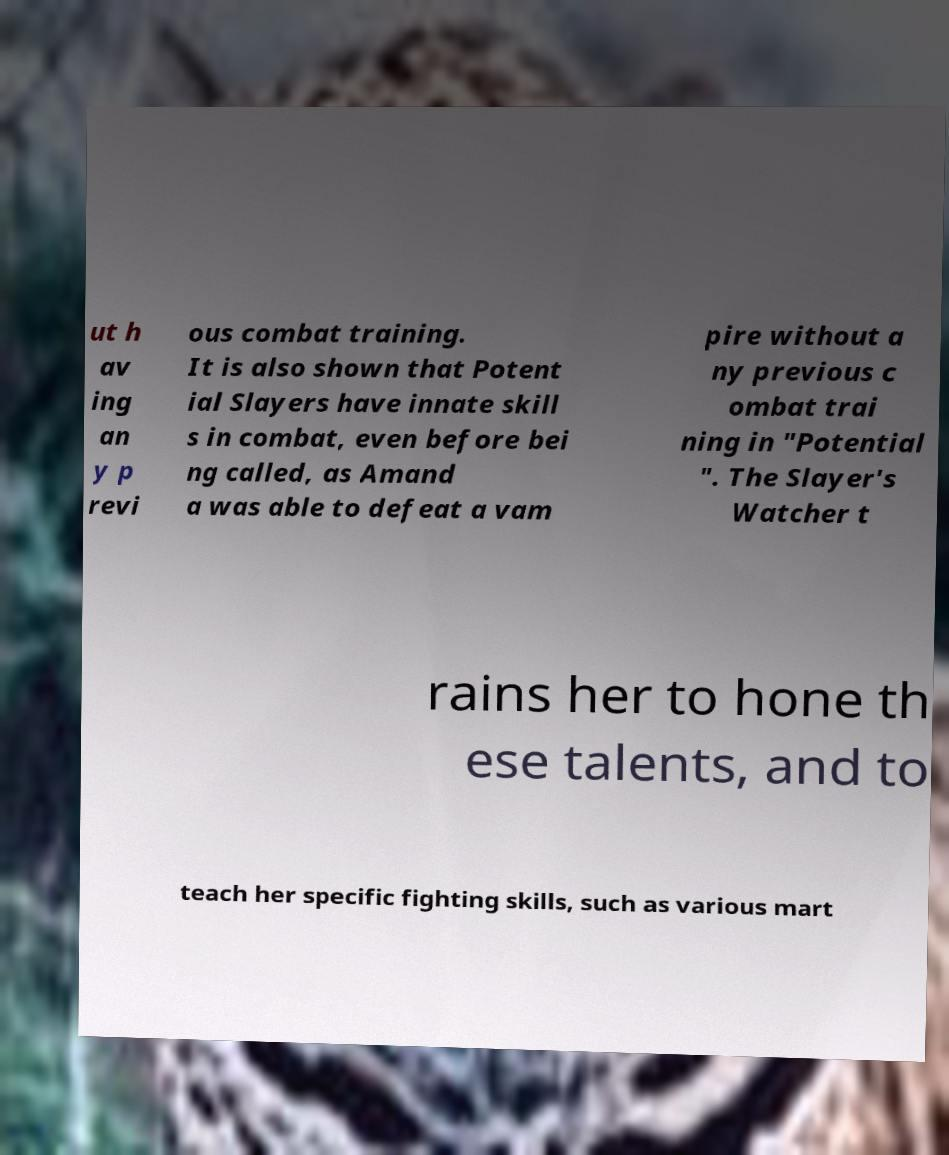Please identify and transcribe the text found in this image. ut h av ing an y p revi ous combat training. It is also shown that Potent ial Slayers have innate skill s in combat, even before bei ng called, as Amand a was able to defeat a vam pire without a ny previous c ombat trai ning in "Potential ". The Slayer's Watcher t rains her to hone th ese talents, and to teach her specific fighting skills, such as various mart 